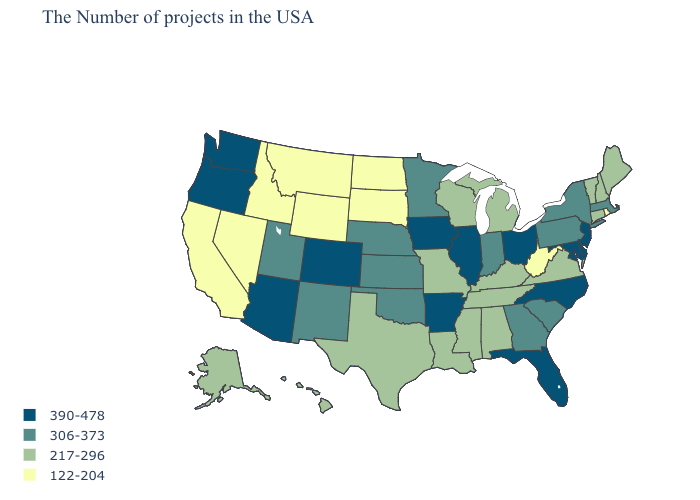What is the lowest value in the USA?
Keep it brief. 122-204. Name the states that have a value in the range 122-204?
Be succinct. Rhode Island, West Virginia, South Dakota, North Dakota, Wyoming, Montana, Idaho, Nevada, California. Among the states that border Michigan , does Wisconsin have the highest value?
Short answer required. No. Which states have the lowest value in the USA?
Quick response, please. Rhode Island, West Virginia, South Dakota, North Dakota, Wyoming, Montana, Idaho, Nevada, California. Does Colorado have the highest value in the West?
Answer briefly. Yes. What is the value of Georgia?
Give a very brief answer. 306-373. Does the map have missing data?
Give a very brief answer. No. What is the value of Montana?
Write a very short answer. 122-204. Which states hav the highest value in the MidWest?
Be succinct. Ohio, Illinois, Iowa. Name the states that have a value in the range 306-373?
Answer briefly. Massachusetts, New York, Pennsylvania, South Carolina, Georgia, Indiana, Minnesota, Kansas, Nebraska, Oklahoma, New Mexico, Utah. What is the lowest value in states that border Arizona?
Answer briefly. 122-204. What is the value of New Jersey?
Give a very brief answer. 390-478. What is the value of Georgia?
Short answer required. 306-373. What is the value of Illinois?
Give a very brief answer. 390-478. What is the value of New York?
Concise answer only. 306-373. 